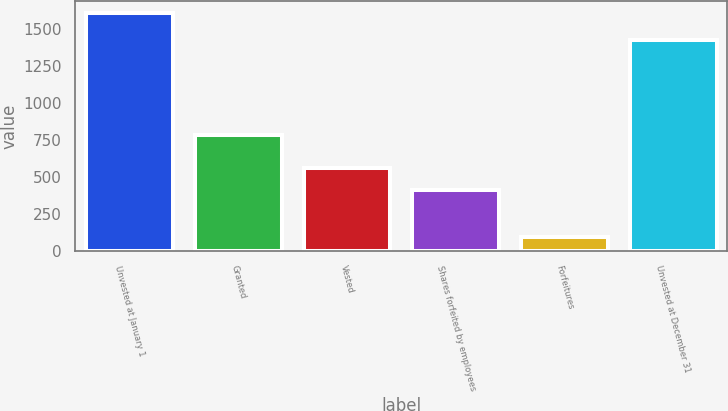Convert chart to OTSL. <chart><loc_0><loc_0><loc_500><loc_500><bar_chart><fcel>Unvested at January 1<fcel>Granted<fcel>Vested<fcel>Shares forfeited by employees<fcel>Forfeitures<fcel>Unvested at December 31<nl><fcel>1607<fcel>785<fcel>563<fcel>412<fcel>97<fcel>1425<nl></chart> 